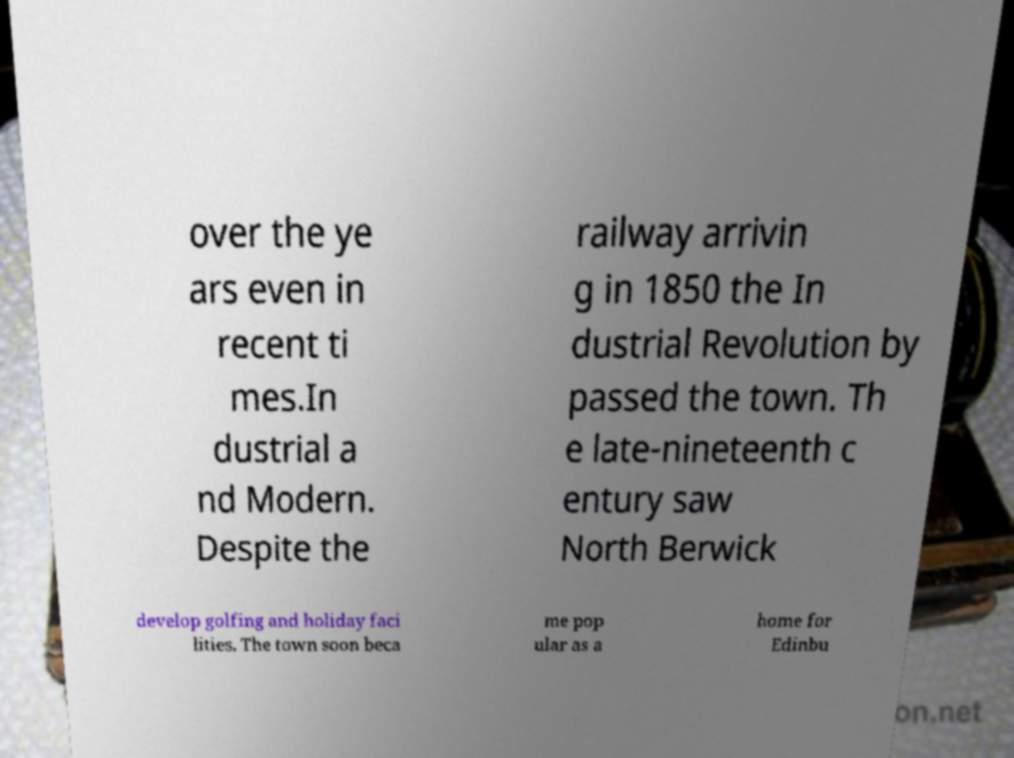Can you read and provide the text displayed in the image?This photo seems to have some interesting text. Can you extract and type it out for me? over the ye ars even in recent ti mes.In dustrial a nd Modern. Despite the railway arrivin g in 1850 the In dustrial Revolution by passed the town. Th e late-nineteenth c entury saw North Berwick develop golfing and holiday faci lities. The town soon beca me pop ular as a home for Edinbu 